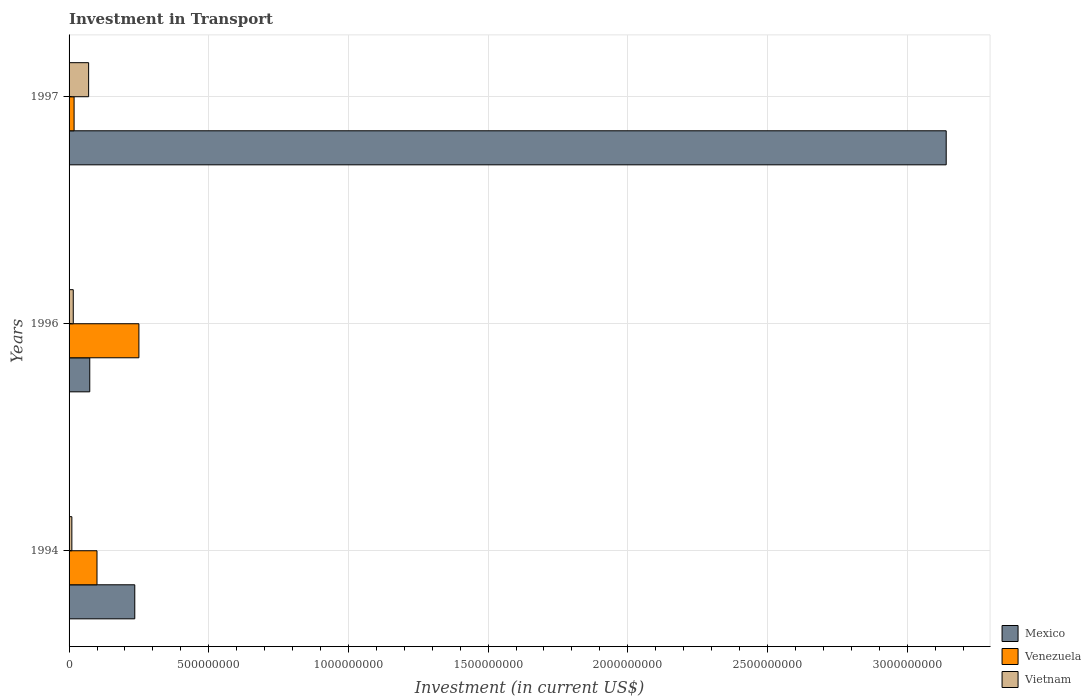How many different coloured bars are there?
Make the answer very short. 3. How many groups of bars are there?
Your answer should be compact. 3. Are the number of bars per tick equal to the number of legend labels?
Your answer should be very brief. Yes. How many bars are there on the 1st tick from the bottom?
Your response must be concise. 3. What is the label of the 3rd group of bars from the top?
Make the answer very short. 1994. In how many cases, is the number of bars for a given year not equal to the number of legend labels?
Make the answer very short. 0. What is the amount invested in transport in Vietnam in 1997?
Give a very brief answer. 7.00e+07. Across all years, what is the maximum amount invested in transport in Vietnam?
Provide a short and direct response. 7.00e+07. Across all years, what is the minimum amount invested in transport in Mexico?
Your answer should be compact. 7.41e+07. In which year was the amount invested in transport in Vietnam maximum?
Provide a succinct answer. 1997. What is the total amount invested in transport in Mexico in the graph?
Provide a succinct answer. 3.45e+09. What is the difference between the amount invested in transport in Vietnam in 1994 and that in 1996?
Your answer should be very brief. -5.00e+06. What is the difference between the amount invested in transport in Vietnam in 1994 and the amount invested in transport in Mexico in 1996?
Make the answer very short. -6.41e+07. What is the average amount invested in transport in Vietnam per year?
Keep it short and to the point. 3.17e+07. In the year 1994, what is the difference between the amount invested in transport in Mexico and amount invested in transport in Venezuela?
Your answer should be very brief. 1.35e+08. In how many years, is the amount invested in transport in Venezuela greater than 3000000000 US$?
Provide a succinct answer. 0. What is the ratio of the amount invested in transport in Venezuela in 1994 to that in 1997?
Ensure brevity in your answer.  5.56. What is the difference between the highest and the second highest amount invested in transport in Vietnam?
Ensure brevity in your answer.  5.50e+07. What is the difference between the highest and the lowest amount invested in transport in Vietnam?
Provide a succinct answer. 6.00e+07. In how many years, is the amount invested in transport in Mexico greater than the average amount invested in transport in Mexico taken over all years?
Keep it short and to the point. 1. Is the sum of the amount invested in transport in Venezuela in 1994 and 1996 greater than the maximum amount invested in transport in Mexico across all years?
Provide a succinct answer. No. What does the 2nd bar from the top in 1994 represents?
Offer a very short reply. Venezuela. What does the 2nd bar from the bottom in 1994 represents?
Offer a terse response. Venezuela. Is it the case that in every year, the sum of the amount invested in transport in Mexico and amount invested in transport in Venezuela is greater than the amount invested in transport in Vietnam?
Your answer should be very brief. Yes. How many bars are there?
Your response must be concise. 9. What is the difference between two consecutive major ticks on the X-axis?
Offer a terse response. 5.00e+08. Does the graph contain any zero values?
Provide a succinct answer. No. Does the graph contain grids?
Make the answer very short. Yes. Where does the legend appear in the graph?
Provide a succinct answer. Bottom right. What is the title of the graph?
Give a very brief answer. Investment in Transport. Does "Afghanistan" appear as one of the legend labels in the graph?
Your answer should be compact. No. What is the label or title of the X-axis?
Offer a terse response. Investment (in current US$). What is the Investment (in current US$) of Mexico in 1994?
Your answer should be very brief. 2.35e+08. What is the Investment (in current US$) of Venezuela in 1994?
Offer a terse response. 1.00e+08. What is the Investment (in current US$) of Mexico in 1996?
Keep it short and to the point. 7.41e+07. What is the Investment (in current US$) of Venezuela in 1996?
Keep it short and to the point. 2.50e+08. What is the Investment (in current US$) in Vietnam in 1996?
Make the answer very short. 1.50e+07. What is the Investment (in current US$) in Mexico in 1997?
Your response must be concise. 3.14e+09. What is the Investment (in current US$) in Venezuela in 1997?
Provide a succinct answer. 1.80e+07. What is the Investment (in current US$) in Vietnam in 1997?
Your answer should be very brief. 7.00e+07. Across all years, what is the maximum Investment (in current US$) of Mexico?
Provide a short and direct response. 3.14e+09. Across all years, what is the maximum Investment (in current US$) of Venezuela?
Your response must be concise. 2.50e+08. Across all years, what is the maximum Investment (in current US$) of Vietnam?
Your answer should be very brief. 7.00e+07. Across all years, what is the minimum Investment (in current US$) of Mexico?
Give a very brief answer. 7.41e+07. Across all years, what is the minimum Investment (in current US$) in Venezuela?
Your response must be concise. 1.80e+07. Across all years, what is the minimum Investment (in current US$) of Vietnam?
Your response must be concise. 1.00e+07. What is the total Investment (in current US$) of Mexico in the graph?
Keep it short and to the point. 3.45e+09. What is the total Investment (in current US$) of Venezuela in the graph?
Your response must be concise. 3.68e+08. What is the total Investment (in current US$) in Vietnam in the graph?
Provide a succinct answer. 9.50e+07. What is the difference between the Investment (in current US$) of Mexico in 1994 and that in 1996?
Make the answer very short. 1.61e+08. What is the difference between the Investment (in current US$) of Venezuela in 1994 and that in 1996?
Offer a very short reply. -1.50e+08. What is the difference between the Investment (in current US$) in Vietnam in 1994 and that in 1996?
Keep it short and to the point. -5.00e+06. What is the difference between the Investment (in current US$) of Mexico in 1994 and that in 1997?
Provide a succinct answer. -2.90e+09. What is the difference between the Investment (in current US$) of Venezuela in 1994 and that in 1997?
Your answer should be compact. 8.20e+07. What is the difference between the Investment (in current US$) of Vietnam in 1994 and that in 1997?
Make the answer very short. -6.00e+07. What is the difference between the Investment (in current US$) in Mexico in 1996 and that in 1997?
Your response must be concise. -3.07e+09. What is the difference between the Investment (in current US$) of Venezuela in 1996 and that in 1997?
Provide a short and direct response. 2.32e+08. What is the difference between the Investment (in current US$) in Vietnam in 1996 and that in 1997?
Give a very brief answer. -5.50e+07. What is the difference between the Investment (in current US$) of Mexico in 1994 and the Investment (in current US$) of Venezuela in 1996?
Keep it short and to the point. -1.48e+07. What is the difference between the Investment (in current US$) of Mexico in 1994 and the Investment (in current US$) of Vietnam in 1996?
Offer a very short reply. 2.20e+08. What is the difference between the Investment (in current US$) of Venezuela in 1994 and the Investment (in current US$) of Vietnam in 1996?
Keep it short and to the point. 8.50e+07. What is the difference between the Investment (in current US$) in Mexico in 1994 and the Investment (in current US$) in Venezuela in 1997?
Give a very brief answer. 2.17e+08. What is the difference between the Investment (in current US$) in Mexico in 1994 and the Investment (in current US$) in Vietnam in 1997?
Offer a terse response. 1.65e+08. What is the difference between the Investment (in current US$) of Venezuela in 1994 and the Investment (in current US$) of Vietnam in 1997?
Offer a terse response. 3.00e+07. What is the difference between the Investment (in current US$) in Mexico in 1996 and the Investment (in current US$) in Venezuela in 1997?
Give a very brief answer. 5.61e+07. What is the difference between the Investment (in current US$) of Mexico in 1996 and the Investment (in current US$) of Vietnam in 1997?
Ensure brevity in your answer.  4.10e+06. What is the difference between the Investment (in current US$) in Venezuela in 1996 and the Investment (in current US$) in Vietnam in 1997?
Your answer should be compact. 1.80e+08. What is the average Investment (in current US$) in Mexico per year?
Keep it short and to the point. 1.15e+09. What is the average Investment (in current US$) of Venezuela per year?
Your response must be concise. 1.23e+08. What is the average Investment (in current US$) in Vietnam per year?
Offer a very short reply. 3.17e+07. In the year 1994, what is the difference between the Investment (in current US$) in Mexico and Investment (in current US$) in Venezuela?
Give a very brief answer. 1.35e+08. In the year 1994, what is the difference between the Investment (in current US$) of Mexico and Investment (in current US$) of Vietnam?
Provide a short and direct response. 2.25e+08. In the year 1994, what is the difference between the Investment (in current US$) in Venezuela and Investment (in current US$) in Vietnam?
Your response must be concise. 9.00e+07. In the year 1996, what is the difference between the Investment (in current US$) of Mexico and Investment (in current US$) of Venezuela?
Your response must be concise. -1.76e+08. In the year 1996, what is the difference between the Investment (in current US$) in Mexico and Investment (in current US$) in Vietnam?
Make the answer very short. 5.91e+07. In the year 1996, what is the difference between the Investment (in current US$) in Venezuela and Investment (in current US$) in Vietnam?
Ensure brevity in your answer.  2.35e+08. In the year 1997, what is the difference between the Investment (in current US$) of Mexico and Investment (in current US$) of Venezuela?
Offer a terse response. 3.12e+09. In the year 1997, what is the difference between the Investment (in current US$) of Mexico and Investment (in current US$) of Vietnam?
Offer a terse response. 3.07e+09. In the year 1997, what is the difference between the Investment (in current US$) of Venezuela and Investment (in current US$) of Vietnam?
Provide a short and direct response. -5.20e+07. What is the ratio of the Investment (in current US$) of Mexico in 1994 to that in 1996?
Give a very brief answer. 3.17. What is the ratio of the Investment (in current US$) in Venezuela in 1994 to that in 1996?
Your answer should be very brief. 0.4. What is the ratio of the Investment (in current US$) of Vietnam in 1994 to that in 1996?
Give a very brief answer. 0.67. What is the ratio of the Investment (in current US$) of Mexico in 1994 to that in 1997?
Provide a succinct answer. 0.07. What is the ratio of the Investment (in current US$) of Venezuela in 1994 to that in 1997?
Give a very brief answer. 5.56. What is the ratio of the Investment (in current US$) of Vietnam in 1994 to that in 1997?
Provide a succinct answer. 0.14. What is the ratio of the Investment (in current US$) in Mexico in 1996 to that in 1997?
Give a very brief answer. 0.02. What is the ratio of the Investment (in current US$) of Venezuela in 1996 to that in 1997?
Offer a very short reply. 13.89. What is the ratio of the Investment (in current US$) of Vietnam in 1996 to that in 1997?
Your answer should be very brief. 0.21. What is the difference between the highest and the second highest Investment (in current US$) of Mexico?
Offer a terse response. 2.90e+09. What is the difference between the highest and the second highest Investment (in current US$) of Venezuela?
Make the answer very short. 1.50e+08. What is the difference between the highest and the second highest Investment (in current US$) in Vietnam?
Make the answer very short. 5.50e+07. What is the difference between the highest and the lowest Investment (in current US$) in Mexico?
Offer a terse response. 3.07e+09. What is the difference between the highest and the lowest Investment (in current US$) of Venezuela?
Provide a short and direct response. 2.32e+08. What is the difference between the highest and the lowest Investment (in current US$) of Vietnam?
Ensure brevity in your answer.  6.00e+07. 